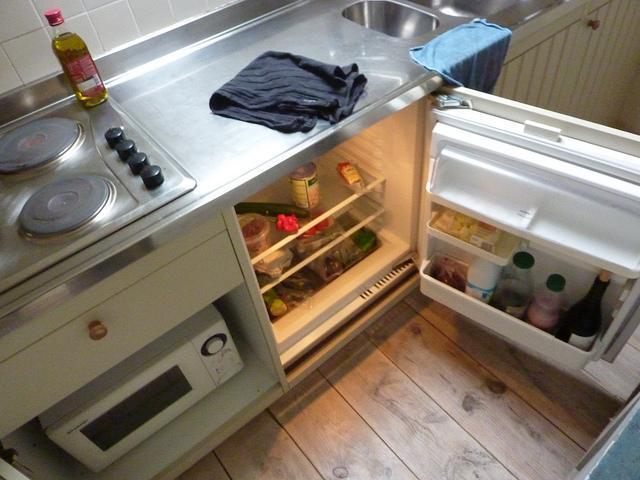How many bottles can be seen?
Give a very brief answer. 2. 